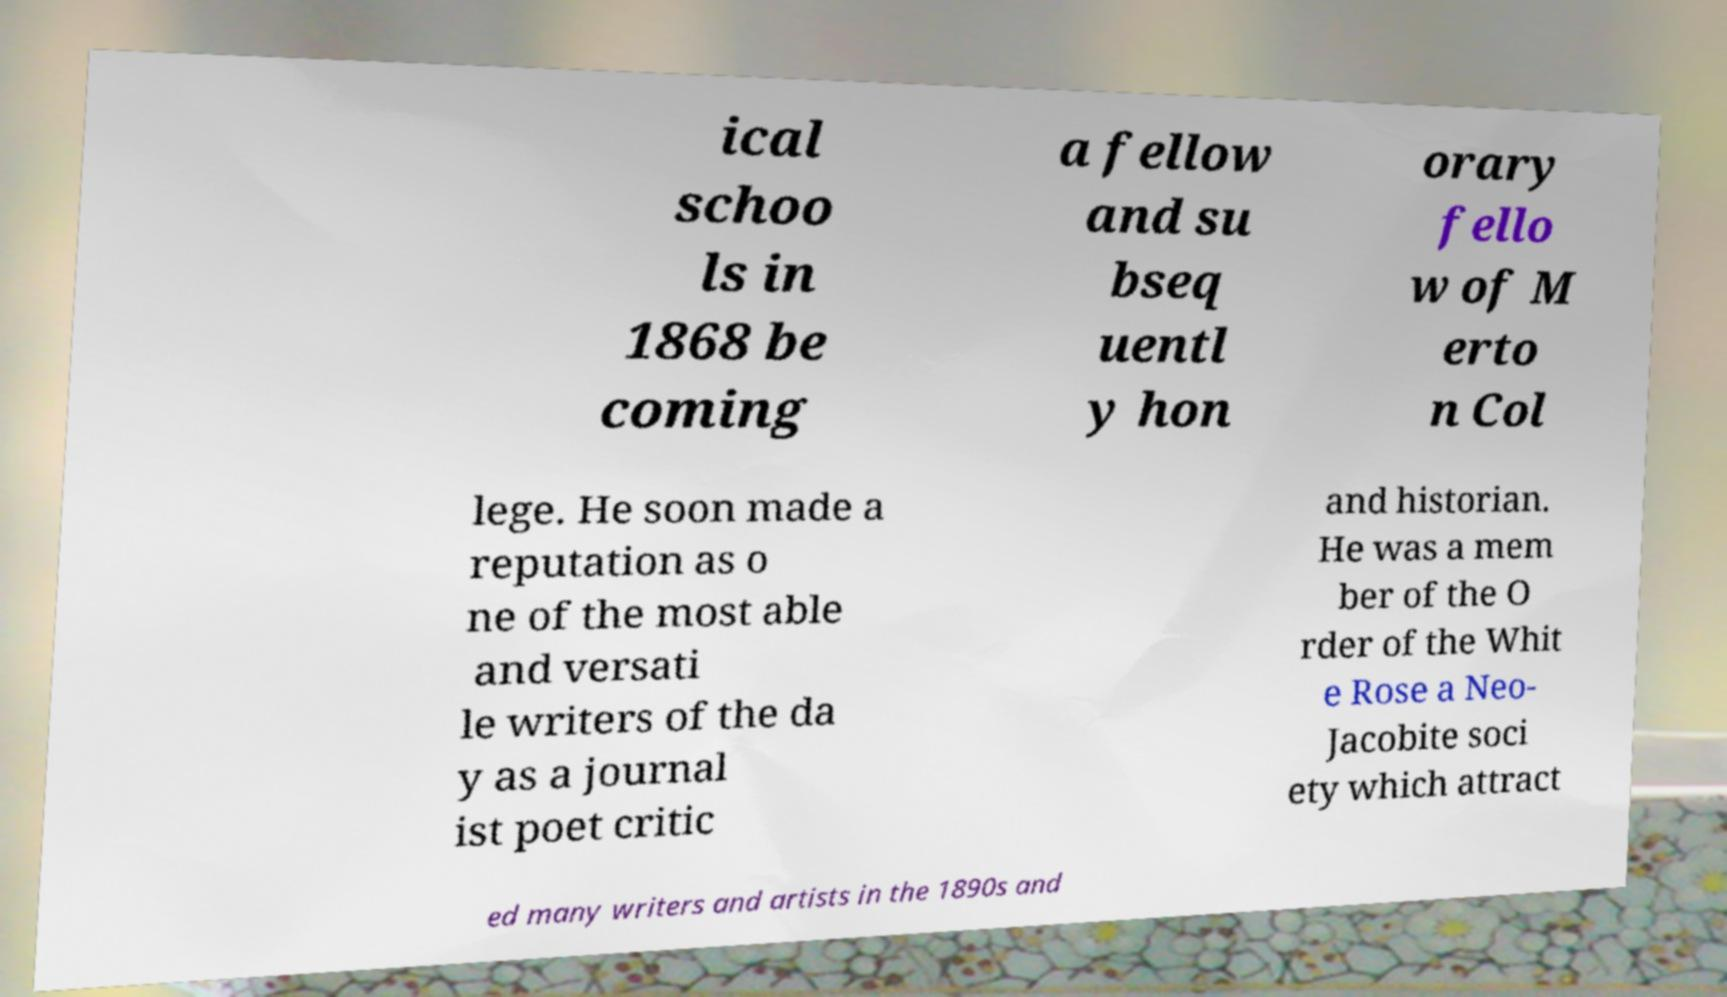There's text embedded in this image that I need extracted. Can you transcribe it verbatim? ical schoo ls in 1868 be coming a fellow and su bseq uentl y hon orary fello w of M erto n Col lege. He soon made a reputation as o ne of the most able and versati le writers of the da y as a journal ist poet critic and historian. He was a mem ber of the O rder of the Whit e Rose a Neo- Jacobite soci ety which attract ed many writers and artists in the 1890s and 